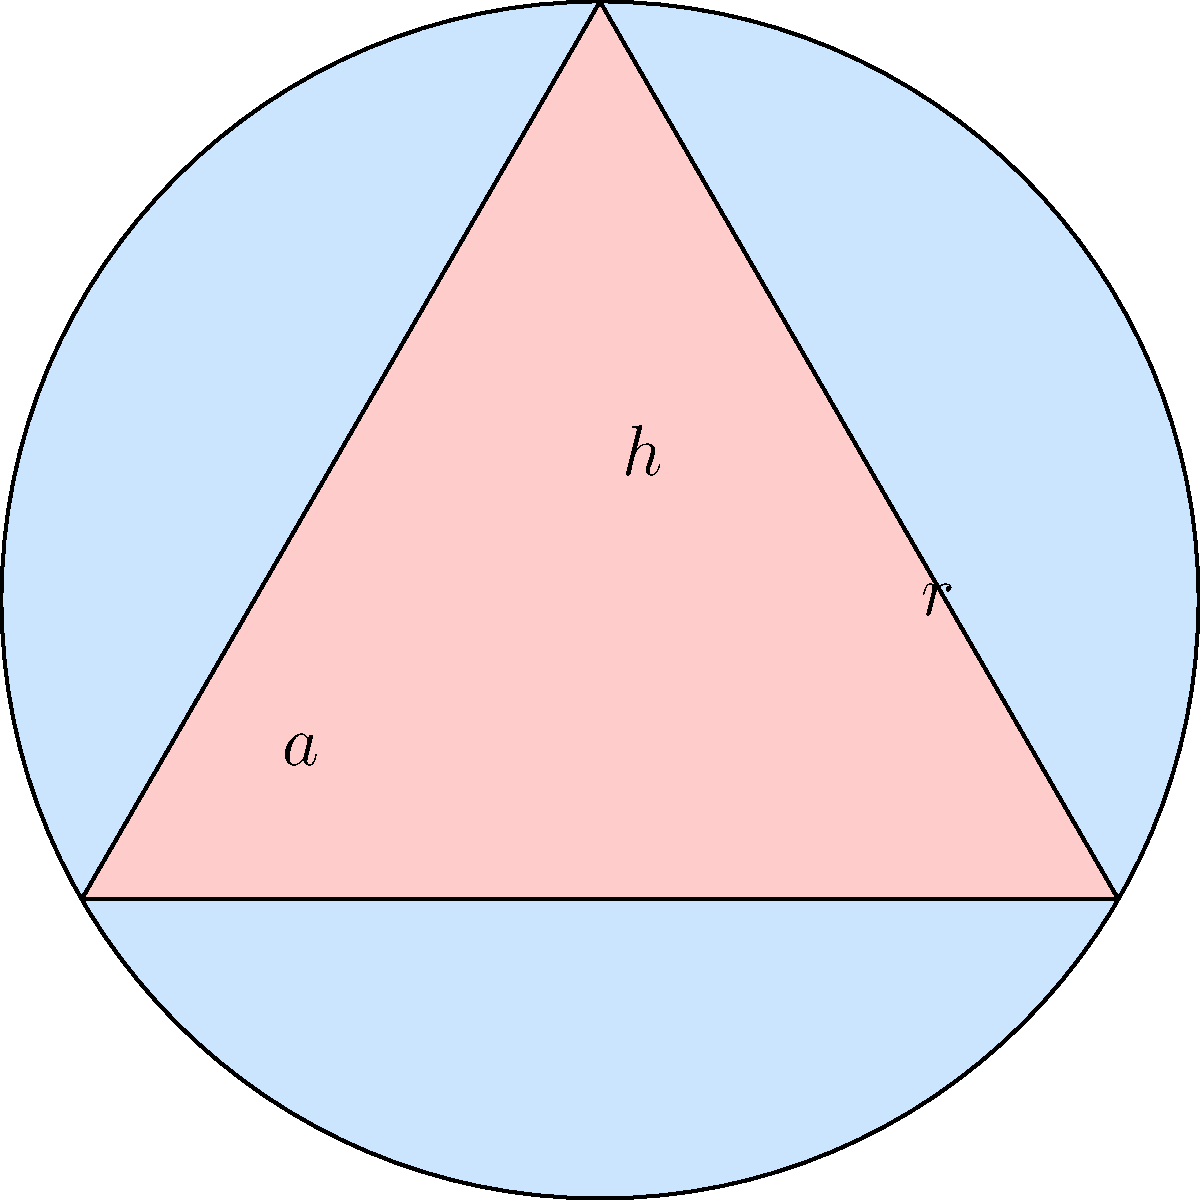A church is designing a stained glass window that consists of a circular section with a triangular section inscribed within it. The radius of the circular section is 6 feet, and the base of the triangular section spans the entire diameter of the circle. What is the total area of colored glass in the window, rounded to the nearest square foot? Let's approach this step-by-step:

1) First, we need to calculate the area of the circular section:
   $$A_{circle} = \pi r^2 = \pi (6^2) = 36\pi \approx 113.10 \text{ sq ft}$$

2) Next, we need to find the area of the triangular section:
   - The base of the triangle is the diameter of the circle: $2r = 12 \text{ ft}$
   - The height of the triangle is the radius: $6 \text{ ft}$
   - Area of a triangle: $A_{triangle} = \frac{1}{2} \times base \times height$
   $$A_{triangle} = \frac{1}{2} \times 12 \times 6 = 36 \text{ sq ft}$$

3) The total colored area is the difference between the circle and triangle areas:
   $$A_{total} = A_{circle} - A_{triangle} = 113.10 - 36 = 77.10 \text{ sq ft}$$

4) Rounding to the nearest square foot:
   $$A_{total} \approx 77 \text{ sq ft}$$

This design symbolizes the Trinity (triangle) encompassed by God's eternal nature (circle), reflecting your journey from agnosticism to Christianity.
Answer: 77 sq ft 